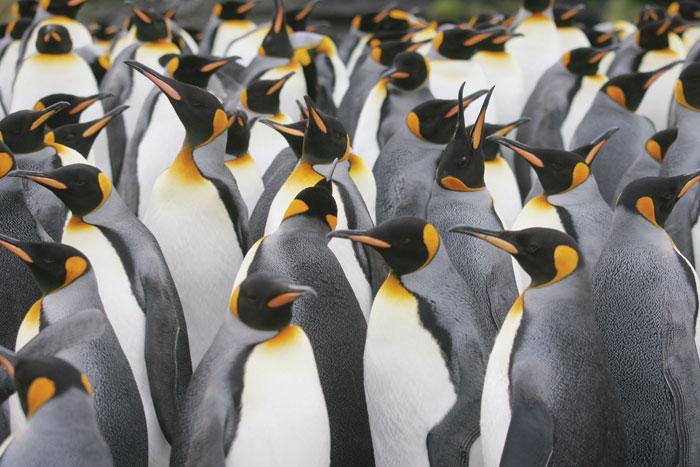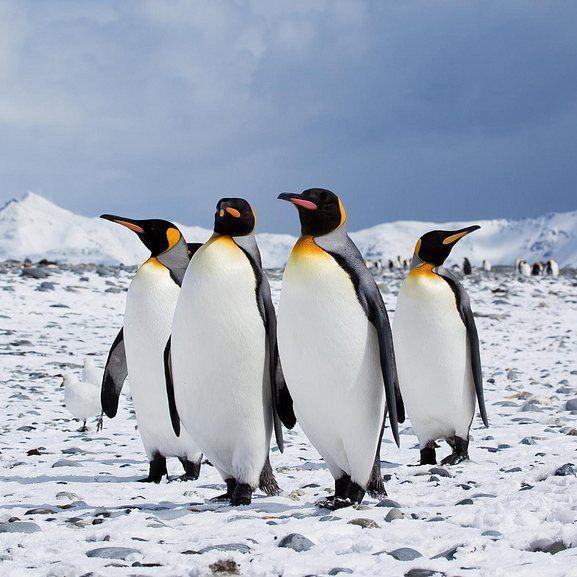The first image is the image on the left, the second image is the image on the right. For the images displayed, is the sentence "A group of four penguins is walking together in the image on the right." factually correct? Answer yes or no. Yes. The first image is the image on the left, the second image is the image on the right. Assess this claim about the two images: "The penguins in one image are in splashing water, while those in the other image are standing on solid, dry ground.". Correct or not? Answer yes or no. No. 